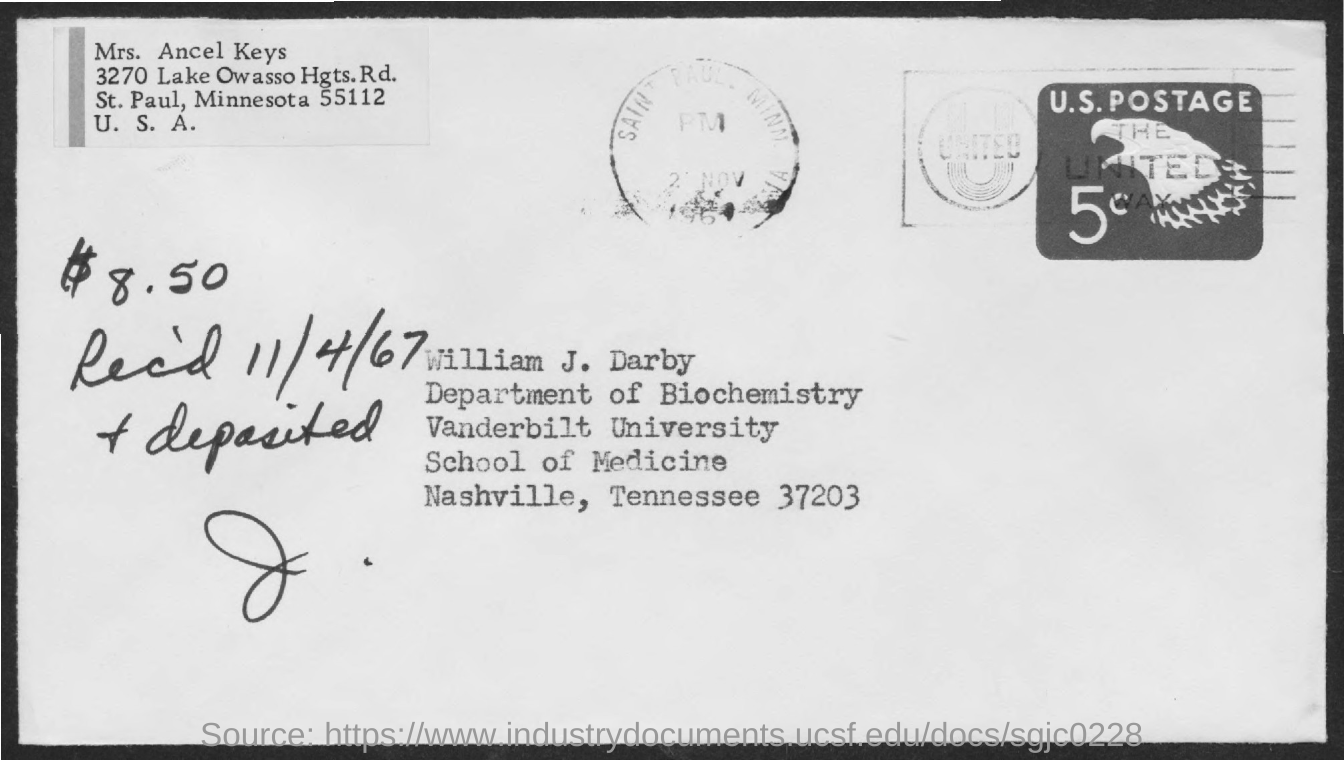List a handful of essential elements in this visual. The amount deposited is $8.50. The received date mentioned on the postal card is 11/4/67. William J. Darby is from Vanderbilt University, as stated in the address. 